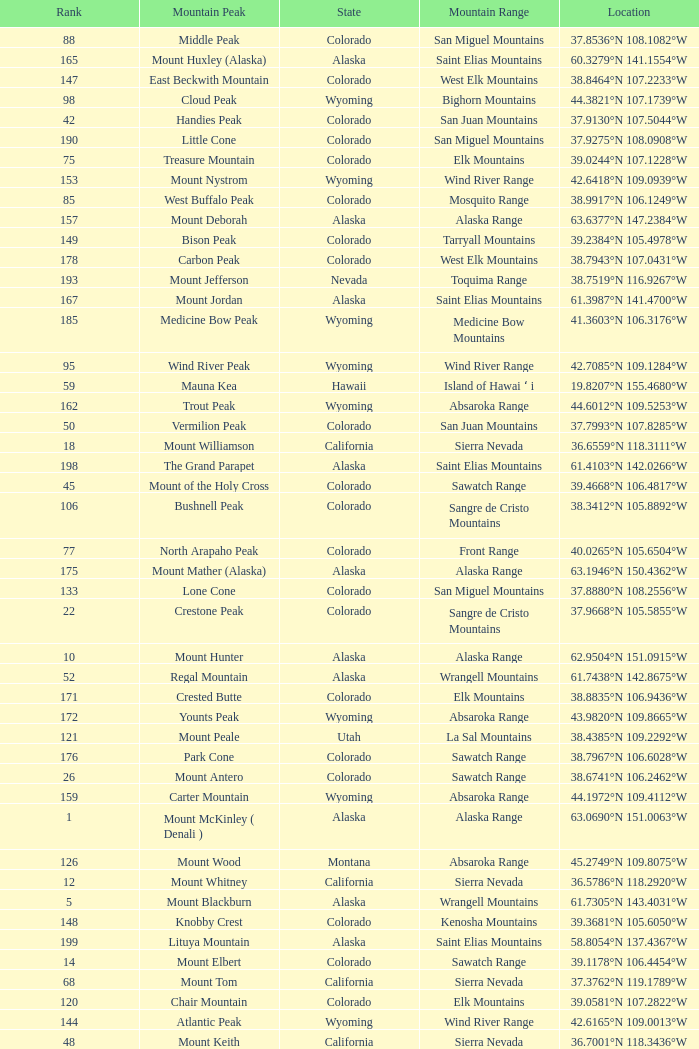What is the mountain range when the mountain peak is mauna kea? Island of Hawai ʻ i. 